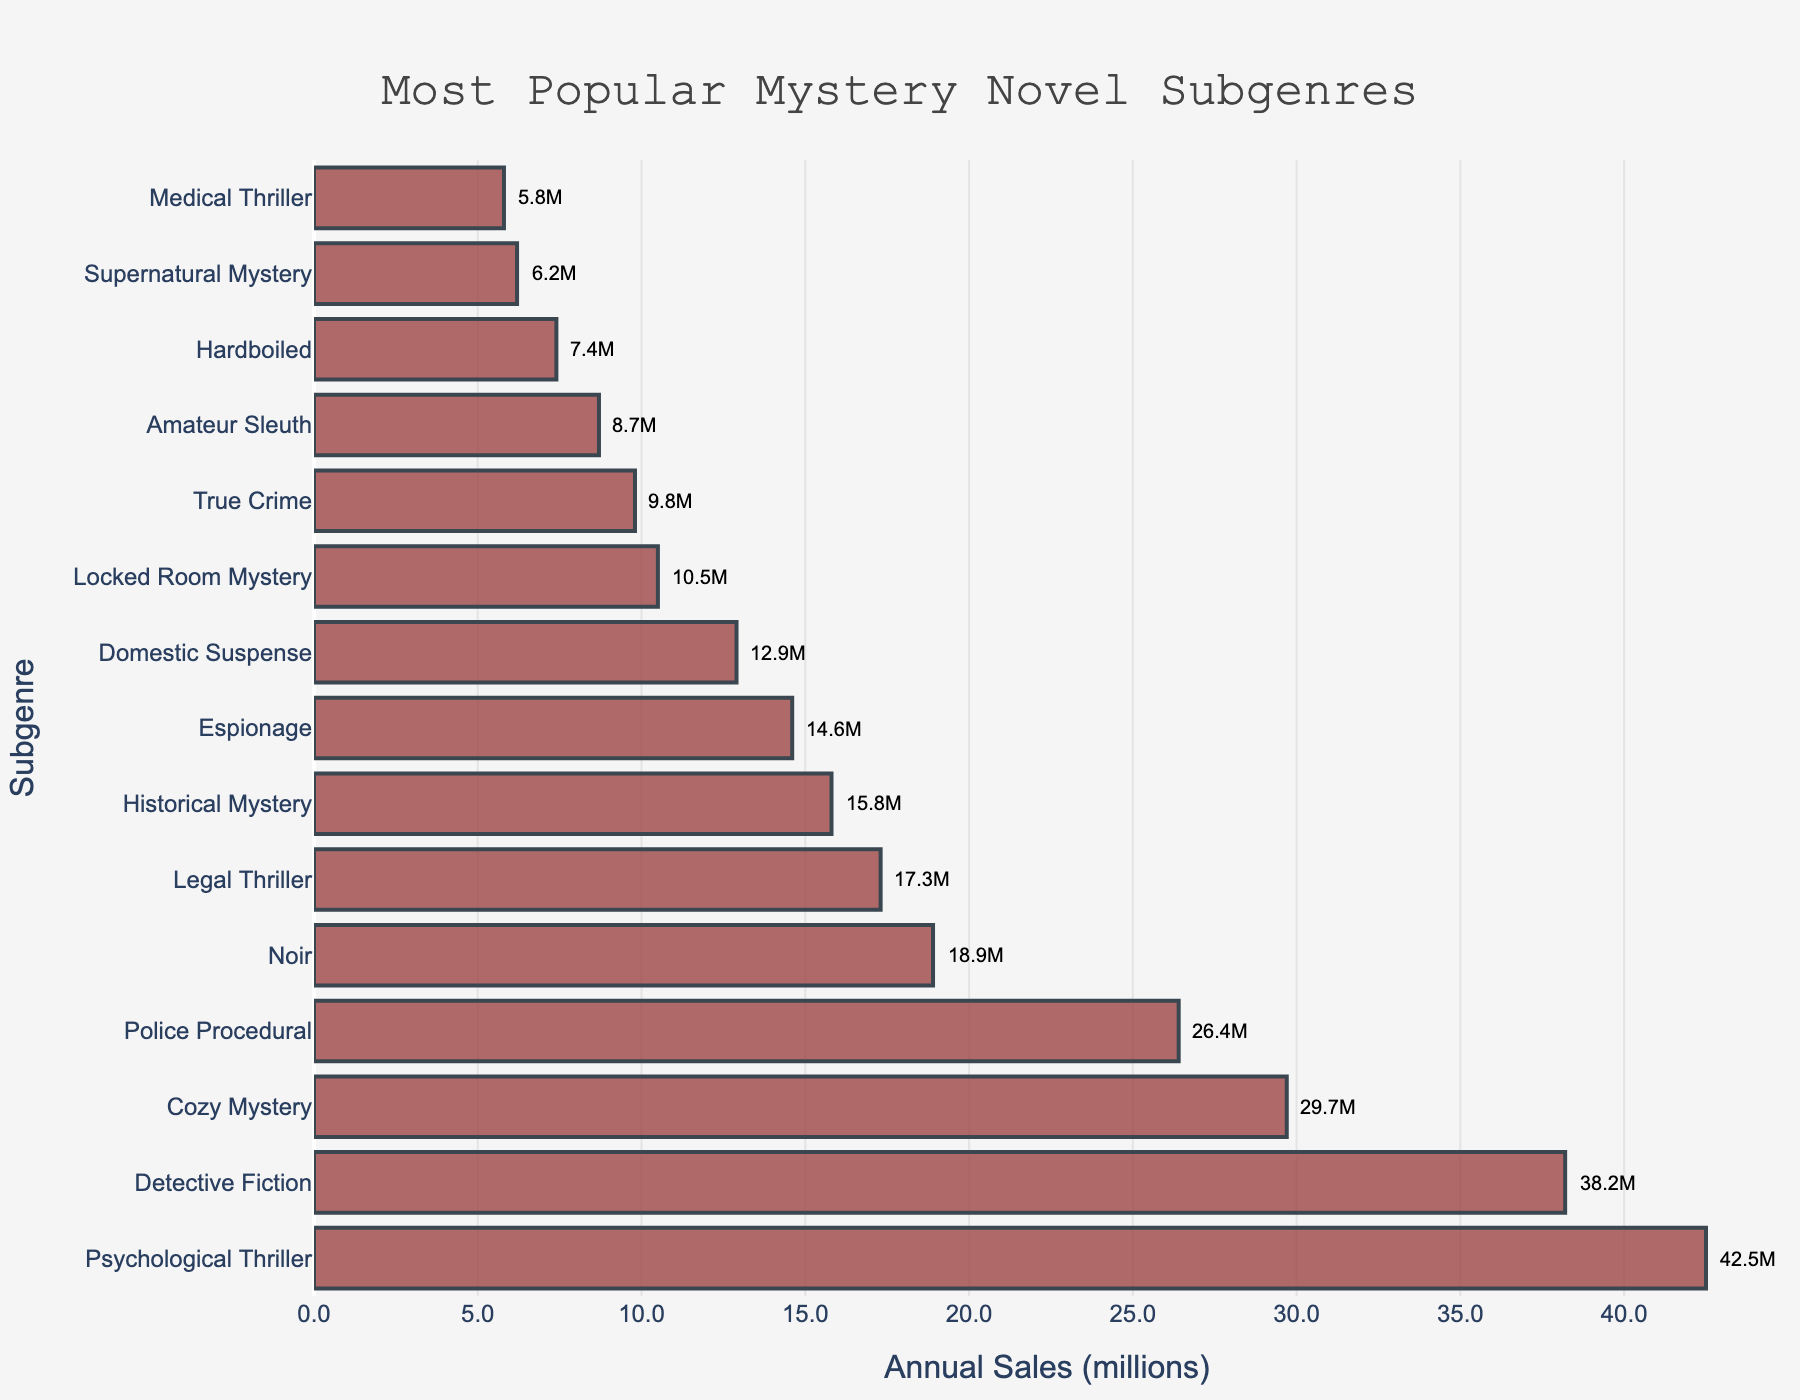Which subgenre has the highest annual sales? The highest bar in the chart represents the subgenre with the highest annual sales. The label for this bar is "Psychological Thriller," showing 42.5 million in annual sales.
Answer: Psychological Thriller Which two subgenres have the closest annual sales figures? Look for the bars that have similar lengths. "Amateur Sleuth" and "Hardboiled" have close sales figures with 8.7 million and 7.4 million, respectively.
Answer: Amateur Sleuth and Hardboiled What's the total annual sales for the top three subgenres? Sum the sales for the top three subgenres: Psychological Thriller (42.5 M), Detective Fiction (38.2 M), and Cozy Mystery (29.7 M). The total is 42.5 + 38.2 + 29.7 = 110.4 million.
Answer: 110.4 million Which subgenre has lower sales: Noir or Legal Thriller? Compare the lengths of the bars for Noir and Legal Thriller. Noir has 18.9 million in sales, while Legal Thriller has 17.3 million. Legal Thriller has lower sales.
Answer: Legal Thriller How much more popular is Psychological Thriller compared to Locked Room Mystery? Subtract the sales of Locked Room Mystery from Psychological Thriller: 42.5 M - 10.5 M = 32 million.
Answer: 32 million What is the average annual sales of the bottom five subgenres? Sum the sales of the bottom five subgenres: Domestic Suspense (12.9 M), Locked Room Mystery (10.5 M), True Crime (9.8 M), Amateur Sleuth (8.7 M), Hardboiled (7.4 M), and Supernatural Mystery (6.2 M). The bottom five are actually the last five including Supernatural Mystery and exclude Medical Thriller. Their sum is 12.9 + 10.5 + 9.8 + 8.7 + 7.4 = 49.3 million. The average is 49.3 / 5 = 9.86 million.
Answer: 9.86 million Which subgenre holds the fifth position in annual sales? Locate the fifth highest bar in the chart. The y-axis label for this bar is "Police Procedural," showing 26.4 million in annual sales.
Answer: Police Procedural Are there more subgenres with sales above 20 million or below 10 million? Count the number of subgenres with sales above 20 million and those with sales below 10 million. There are 4 subgenres with sales above 20 million (Psychological Thriller, Detective Fiction, Cozy Mystery, Police Procedural) and 3 subgenres with sales below 10 million (True Crime, Amateur Sleuth, Hardboiled).
Answer: Above 20 million What is the combined market share of Noir and Historical Mystery? Sum the sales of Noir (18.9 M) and Historical Mystery (15.8 M): 18.9 + 15.8 = 34.7 million.
Answer: 34.7 million How many subgenres have sales between 10 and 20 million? Identify the bars that fall within the 10 million to 20 million range. These subgenres are: Noir (18.9 M), Legal Thriller (17.3 M), Historical Mystery (15.8 M), and Espionage (14.6 M), and Domestic Suspense (12.9 M). There are 5 subgenres.
Answer: 5 